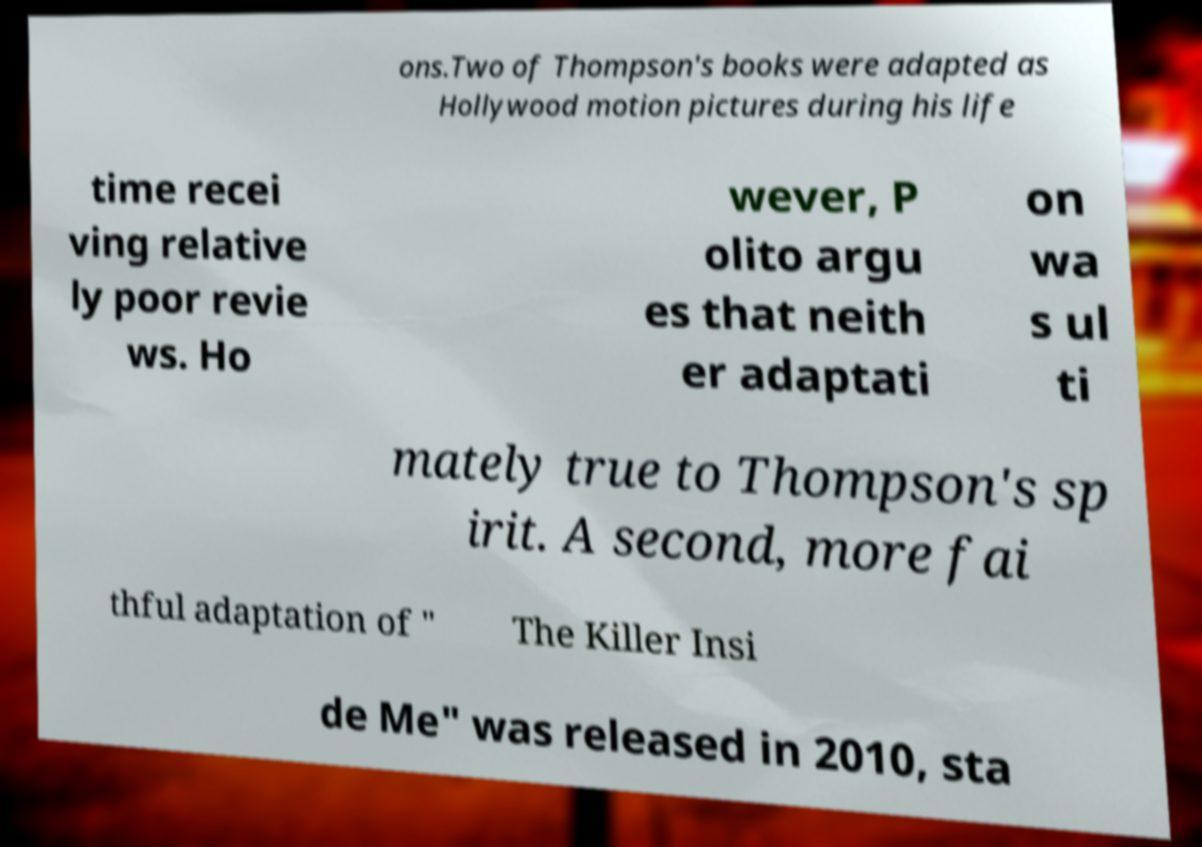Please identify and transcribe the text found in this image. ons.Two of Thompson's books were adapted as Hollywood motion pictures during his life time recei ving relative ly poor revie ws. Ho wever, P olito argu es that neith er adaptati on wa s ul ti mately true to Thompson's sp irit. A second, more fai thful adaptation of " The Killer Insi de Me" was released in 2010, sta 